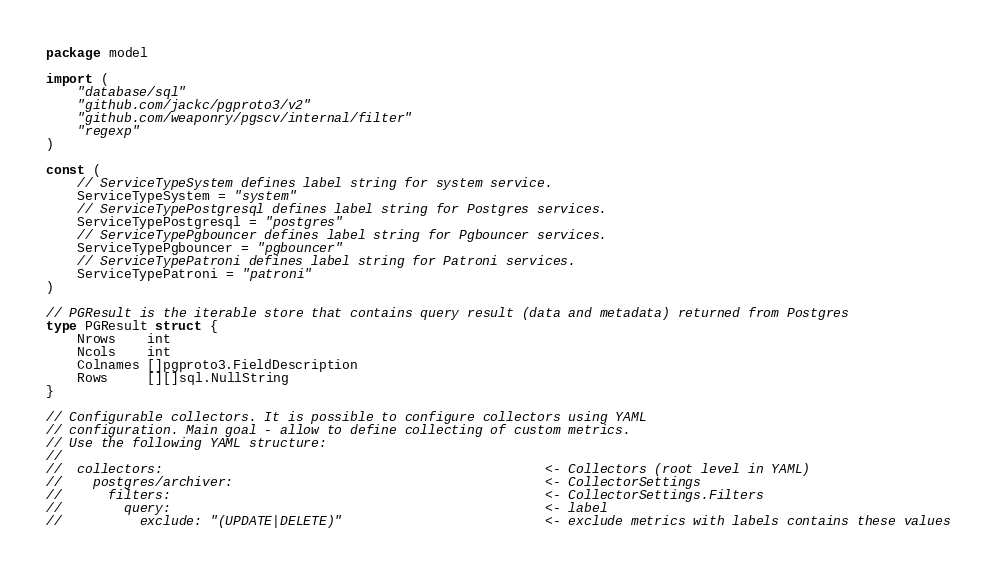<code> <loc_0><loc_0><loc_500><loc_500><_Go_>package model

import (
	"database/sql"
	"github.com/jackc/pgproto3/v2"
	"github.com/weaponry/pgscv/internal/filter"
	"regexp"
)

const (
	// ServiceTypeSystem defines label string for system service.
	ServiceTypeSystem = "system"
	// ServiceTypePostgresql defines label string for Postgres services.
	ServiceTypePostgresql = "postgres"
	// ServiceTypePgbouncer defines label string for Pgbouncer services.
	ServiceTypePgbouncer = "pgbouncer"
	// ServiceTypePatroni defines label string for Patroni services.
	ServiceTypePatroni = "patroni"
)

// PGResult is the iterable store that contains query result (data and metadata) returned from Postgres
type PGResult struct {
	Nrows    int
	Ncols    int
	Colnames []pgproto3.FieldDescription
	Rows     [][]sql.NullString
}

// Configurable collectors. It is possible to configure collectors using YAML
// configuration. Main goal - allow to define collecting of custom metrics.
// Use the following YAML structure:
//
//  collectors:                                                 <- Collectors (root level in YAML)
//    postgres/archiver:                                        <- CollectorSettings
//      filters:                                                <- CollectorSettings.Filters
//        query:                                                <- label
//          exclude: "(UPDATE|DELETE)"                          <- exclude metrics with labels contains these values</code> 